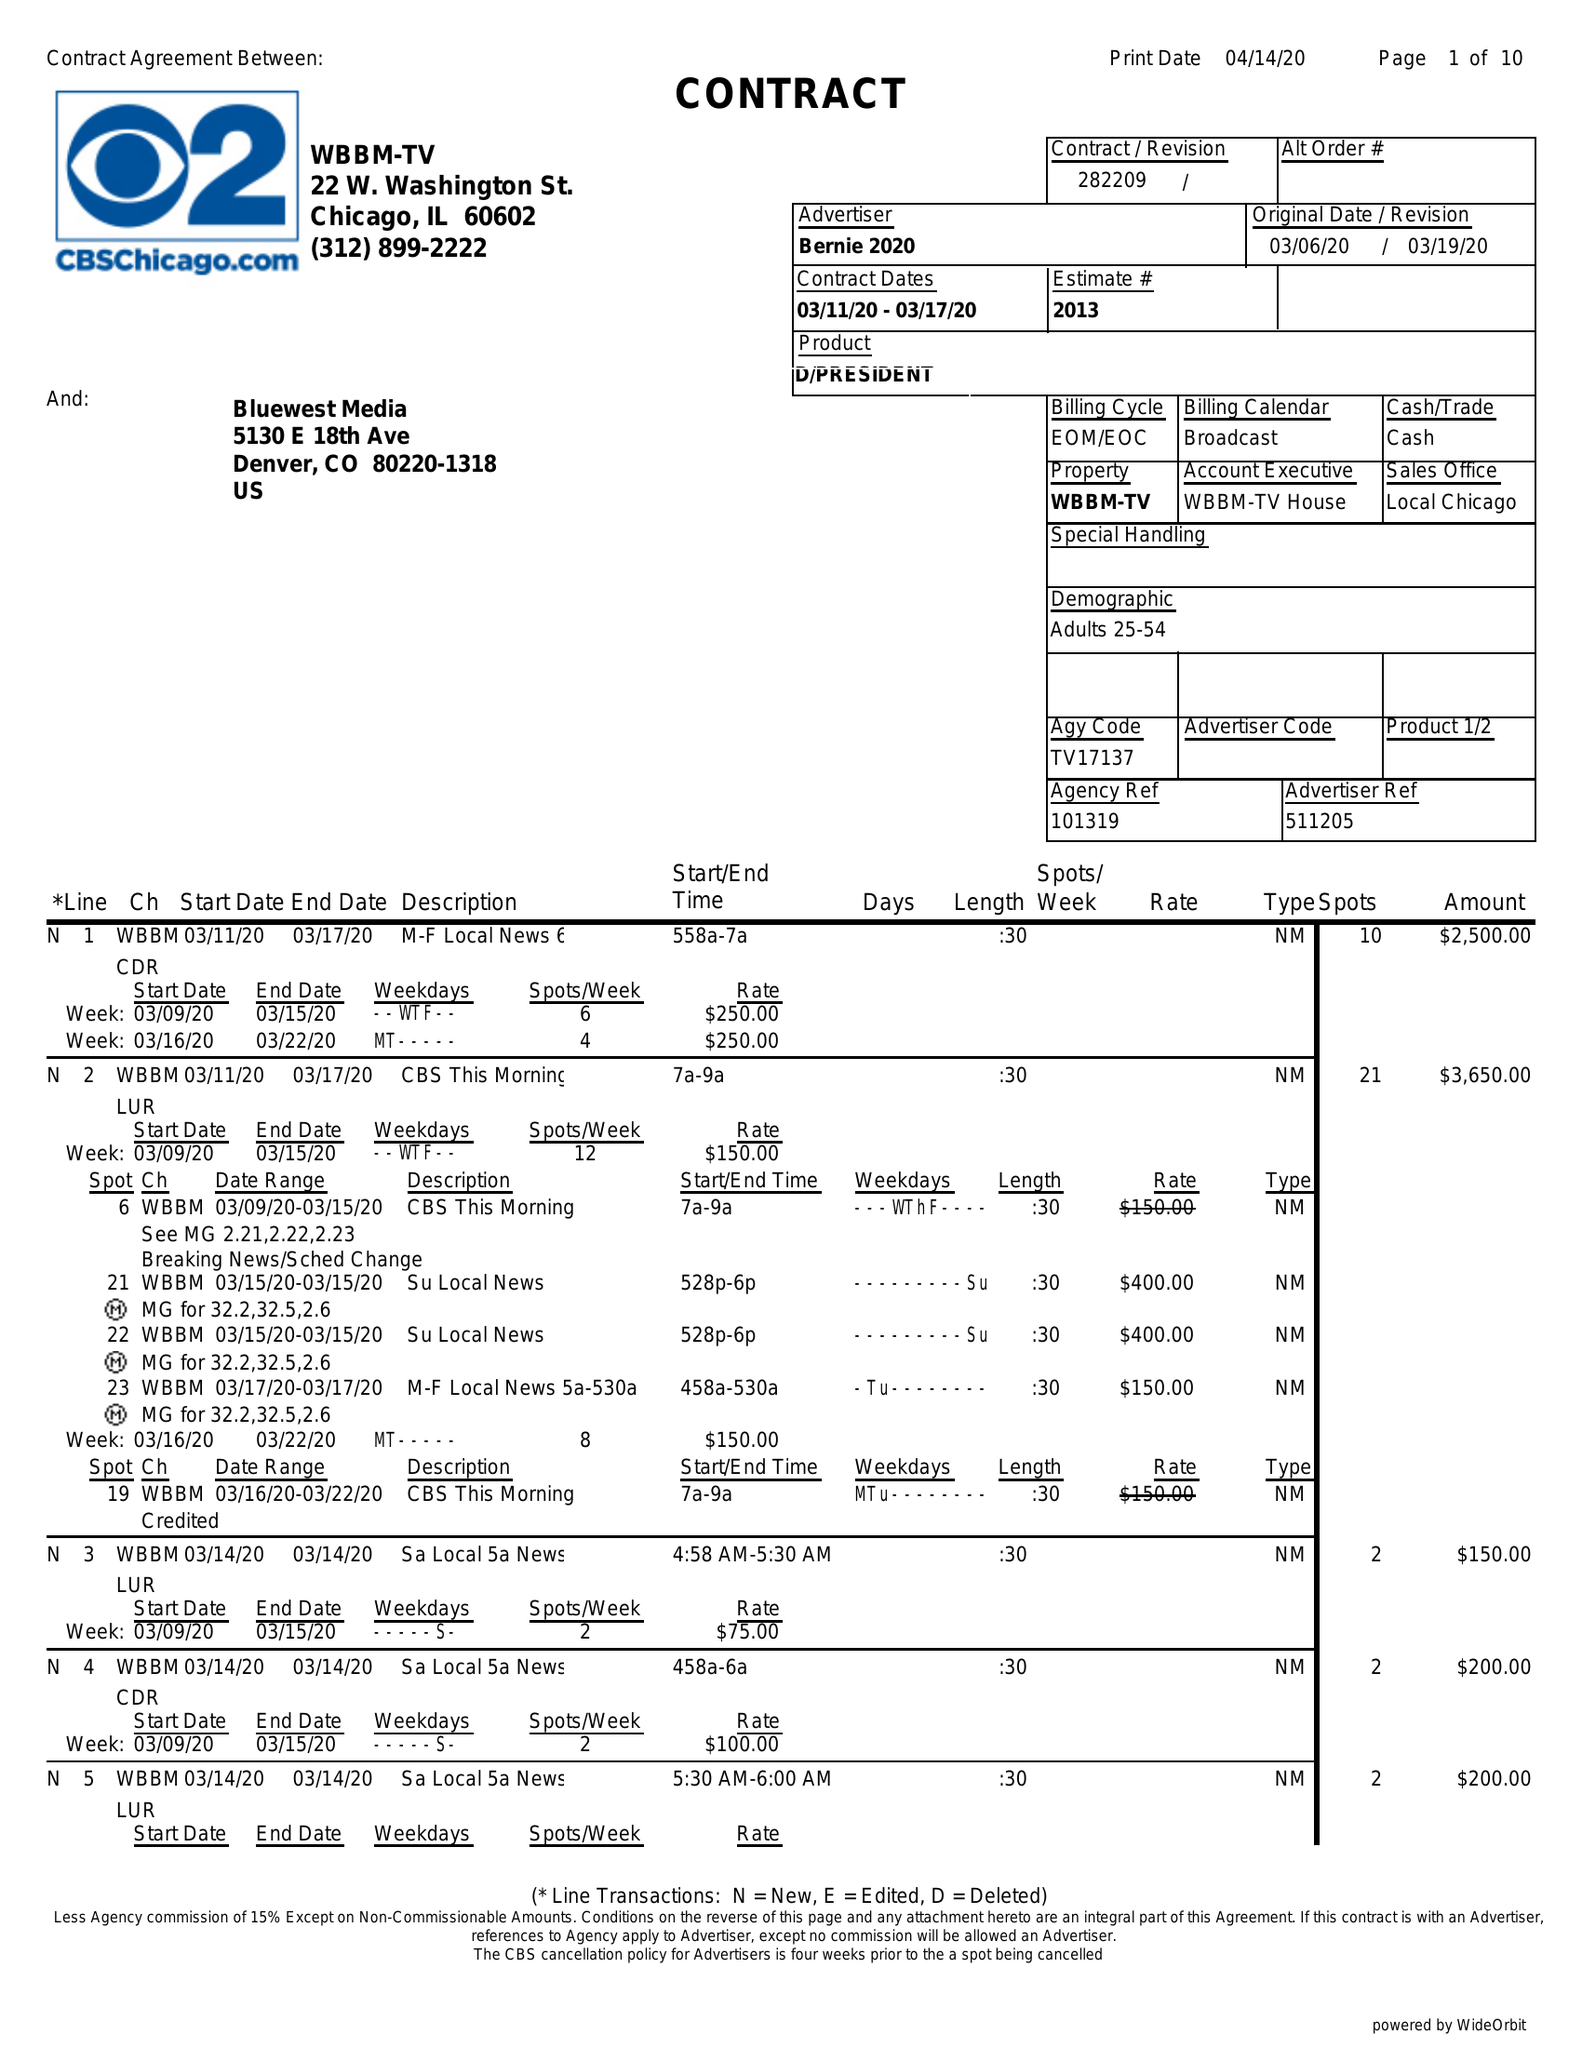What is the value for the advertiser?
Answer the question using a single word or phrase. BERNIE 2020 